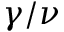Convert formula to latex. <formula><loc_0><loc_0><loc_500><loc_500>\gamma / \nu</formula> 